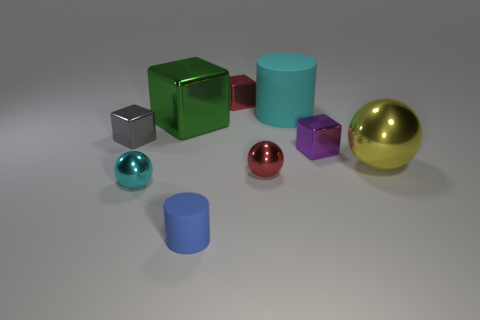Subtract all green spheres. Subtract all cyan cylinders. How many spheres are left? 3 Add 1 purple metal things. How many objects exist? 10 Subtract all balls. How many objects are left? 6 Add 7 tiny cyan spheres. How many tiny cyan spheres are left? 8 Add 1 tiny red cylinders. How many tiny red cylinders exist? 1 Subtract 0 yellow blocks. How many objects are left? 9 Subtract all blue balls. Subtract all tiny metal balls. How many objects are left? 7 